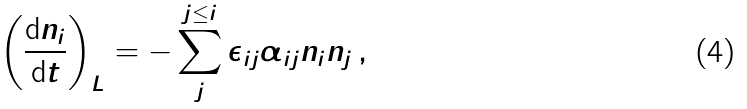<formula> <loc_0><loc_0><loc_500><loc_500>\left ( \frac { \mathrm d n _ { i } } { \mathrm d t } \right ) _ { L } = - \sum _ { j } ^ { j \leq i } \epsilon _ { i j } \alpha _ { i j } n _ { i } n _ { j } \, ,</formula> 